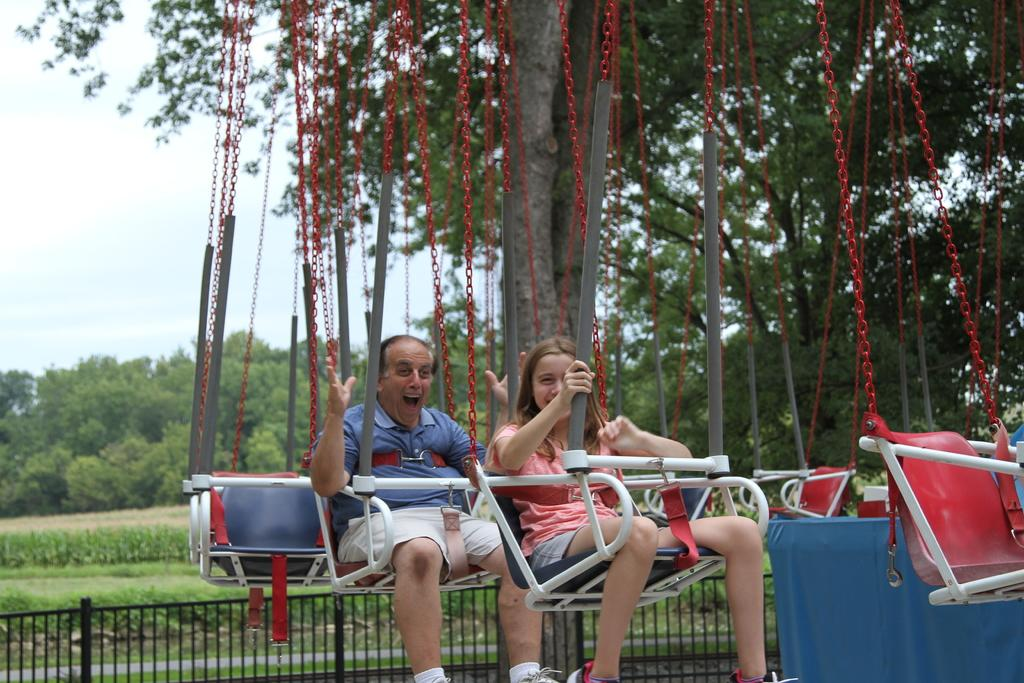Who is present in the image? There is a man and a woman in the image. What are the man and woman doing in the image? The man and woman are sitting on an object and smiling. What can be seen in the background of the image? There is a fence, grass, and the sky visible in the background of the image. What is on the right side of the image? There are objects on the right side of the image. What type of juice is the man drinking in the image? There is no juice present in the image; the man and woman are only shown sitting and smiling. Can you tell me how many apples are on the ground in the image? There are no apples present in the image; the objects on the right side of the image are not specified. 